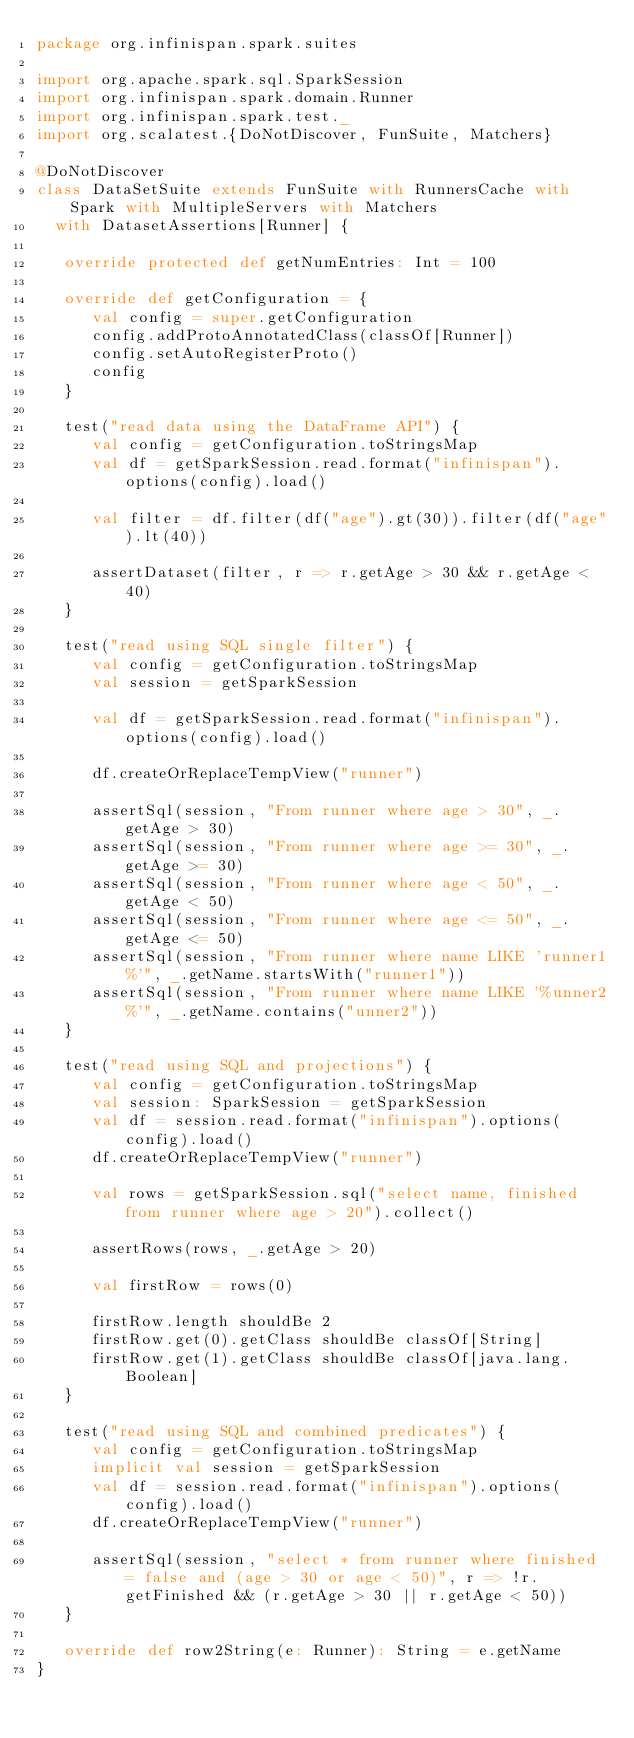<code> <loc_0><loc_0><loc_500><loc_500><_Scala_>package org.infinispan.spark.suites

import org.apache.spark.sql.SparkSession
import org.infinispan.spark.domain.Runner
import org.infinispan.spark.test._
import org.scalatest.{DoNotDiscover, FunSuite, Matchers}

@DoNotDiscover
class DataSetSuite extends FunSuite with RunnersCache with Spark with MultipleServers with Matchers
  with DatasetAssertions[Runner] {

   override protected def getNumEntries: Int = 100

   override def getConfiguration = {
      val config = super.getConfiguration
      config.addProtoAnnotatedClass(classOf[Runner])
      config.setAutoRegisterProto()
      config
   }

   test("read data using the DataFrame API") {
      val config = getConfiguration.toStringsMap
      val df = getSparkSession.read.format("infinispan").options(config).load()

      val filter = df.filter(df("age").gt(30)).filter(df("age").lt(40))

      assertDataset(filter, r => r.getAge > 30 && r.getAge < 40)
   }

   test("read using SQL single filter") {
      val config = getConfiguration.toStringsMap
      val session = getSparkSession

      val df = getSparkSession.read.format("infinispan").options(config).load()

      df.createOrReplaceTempView("runner")

      assertSql(session, "From runner where age > 30", _.getAge > 30)
      assertSql(session, "From runner where age >= 30", _.getAge >= 30)
      assertSql(session, "From runner where age < 50", _.getAge < 50)
      assertSql(session, "From runner where age <= 50", _.getAge <= 50)
      assertSql(session, "From runner where name LIKE 'runner1%'", _.getName.startsWith("runner1"))
      assertSql(session, "From runner where name LIKE '%unner2%'", _.getName.contains("unner2"))
   }

   test("read using SQL and projections") {
      val config = getConfiguration.toStringsMap
      val session: SparkSession = getSparkSession
      val df = session.read.format("infinispan").options(config).load()
      df.createOrReplaceTempView("runner")

      val rows = getSparkSession.sql("select name, finished from runner where age > 20").collect()

      assertRows(rows, _.getAge > 20)

      val firstRow = rows(0)

      firstRow.length shouldBe 2
      firstRow.get(0).getClass shouldBe classOf[String]
      firstRow.get(1).getClass shouldBe classOf[java.lang.Boolean]
   }

   test("read using SQL and combined predicates") {
      val config = getConfiguration.toStringsMap
      implicit val session = getSparkSession
      val df = session.read.format("infinispan").options(config).load()
      df.createOrReplaceTempView("runner")

      assertSql(session, "select * from runner where finished = false and (age > 30 or age < 50)", r => !r.getFinished && (r.getAge > 30 || r.getAge < 50))
   }

   override def row2String(e: Runner): String = e.getName
}
</code> 